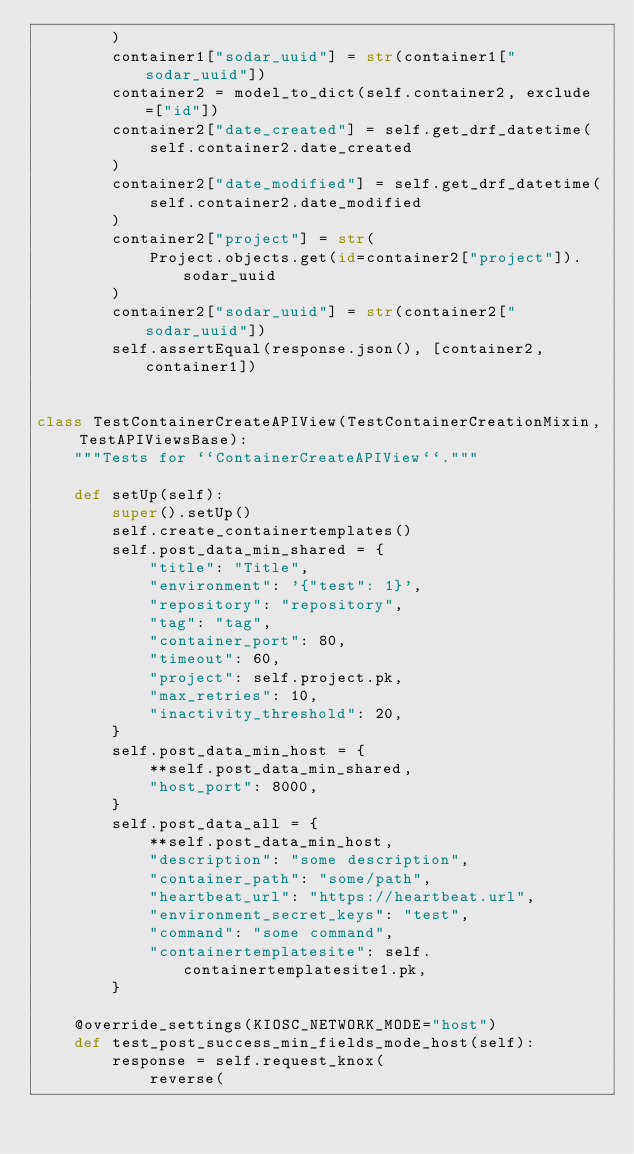<code> <loc_0><loc_0><loc_500><loc_500><_Python_>        )
        container1["sodar_uuid"] = str(container1["sodar_uuid"])
        container2 = model_to_dict(self.container2, exclude=["id"])
        container2["date_created"] = self.get_drf_datetime(
            self.container2.date_created
        )
        container2["date_modified"] = self.get_drf_datetime(
            self.container2.date_modified
        )
        container2["project"] = str(
            Project.objects.get(id=container2["project"]).sodar_uuid
        )
        container2["sodar_uuid"] = str(container2["sodar_uuid"])
        self.assertEqual(response.json(), [container2, container1])


class TestContainerCreateAPIView(TestContainerCreationMixin, TestAPIViewsBase):
    """Tests for ``ContainerCreateAPIView``."""

    def setUp(self):
        super().setUp()
        self.create_containertemplates()
        self.post_data_min_shared = {
            "title": "Title",
            "environment": '{"test": 1}',
            "repository": "repository",
            "tag": "tag",
            "container_port": 80,
            "timeout": 60,
            "project": self.project.pk,
            "max_retries": 10,
            "inactivity_threshold": 20,
        }
        self.post_data_min_host = {
            **self.post_data_min_shared,
            "host_port": 8000,
        }
        self.post_data_all = {
            **self.post_data_min_host,
            "description": "some description",
            "container_path": "some/path",
            "heartbeat_url": "https://heartbeat.url",
            "environment_secret_keys": "test",
            "command": "some command",
            "containertemplatesite": self.containertemplatesite1.pk,
        }

    @override_settings(KIOSC_NETWORK_MODE="host")
    def test_post_success_min_fields_mode_host(self):
        response = self.request_knox(
            reverse(</code> 